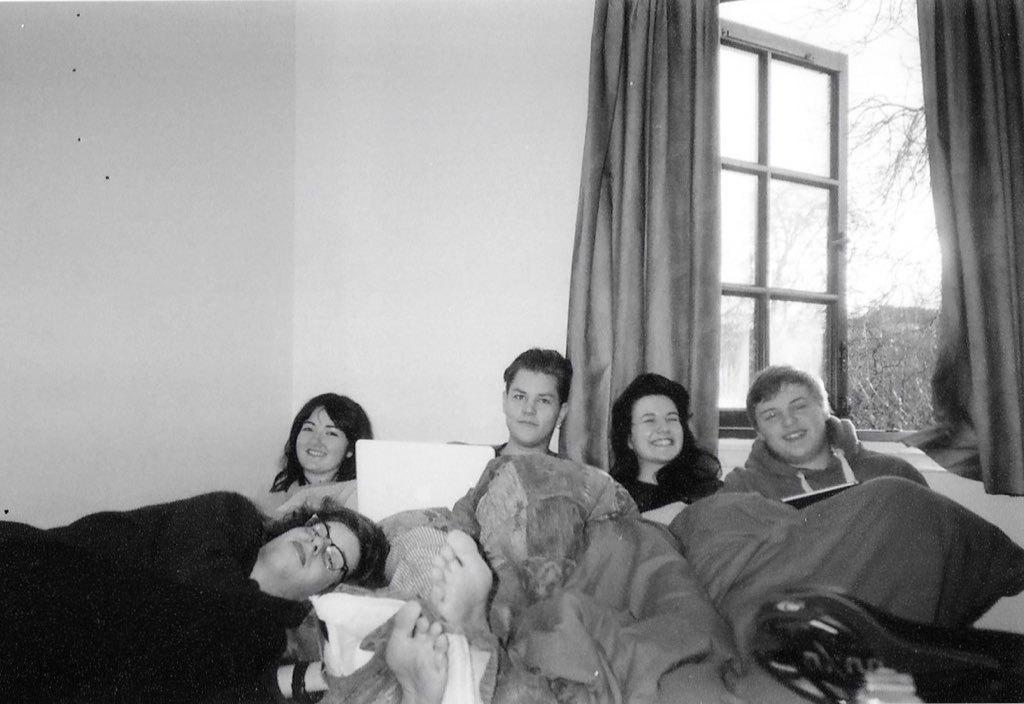How would you summarize this image in a sentence or two? This is a black and white image. In this image we can see people and there are blankets. In the background there is a wall and a window. We can see curtains. There are trees and sky. 